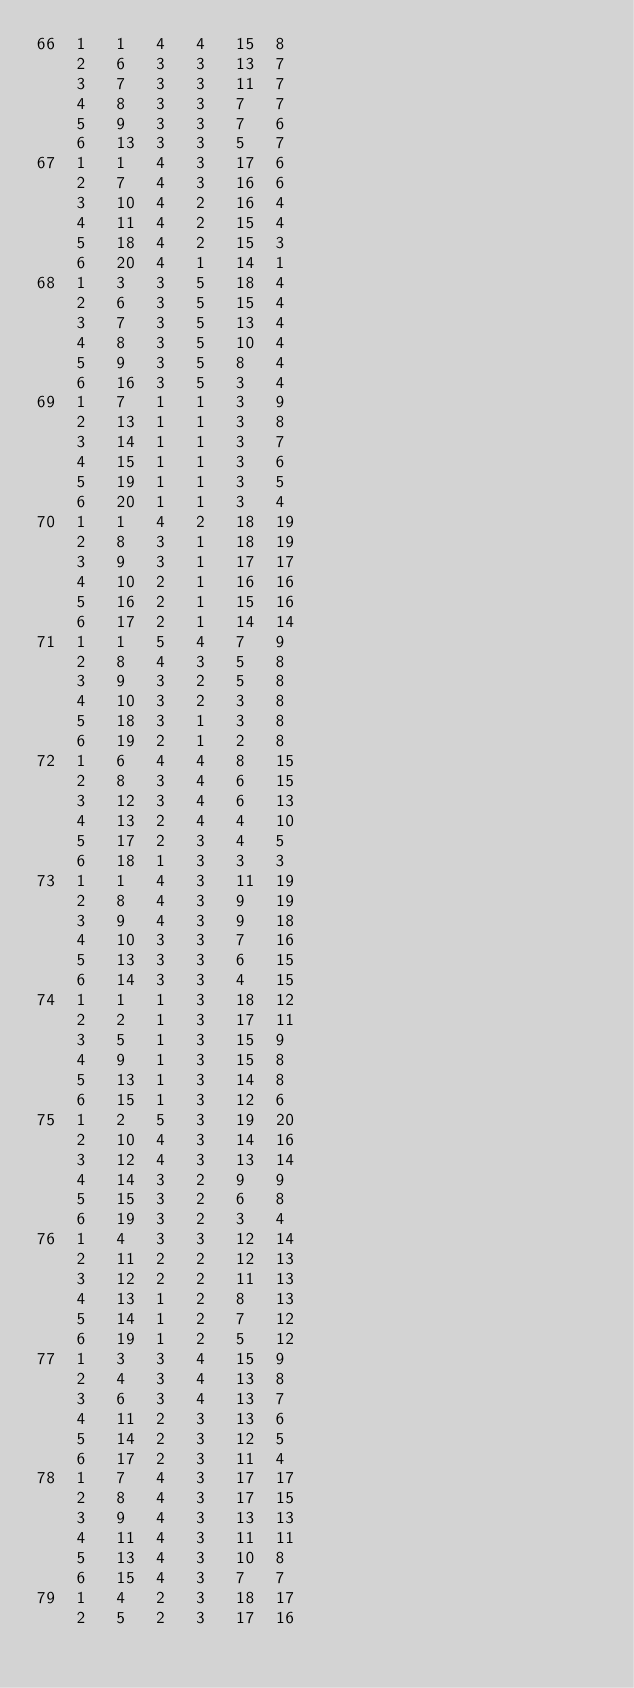<code> <loc_0><loc_0><loc_500><loc_500><_ObjectiveC_>66	1	1	4	4	15	8	
	2	6	3	3	13	7	
	3	7	3	3	11	7	
	4	8	3	3	7	7	
	5	9	3	3	7	6	
	6	13	3	3	5	7	
67	1	1	4	3	17	6	
	2	7	4	3	16	6	
	3	10	4	2	16	4	
	4	11	4	2	15	4	
	5	18	4	2	15	3	
	6	20	4	1	14	1	
68	1	3	3	5	18	4	
	2	6	3	5	15	4	
	3	7	3	5	13	4	
	4	8	3	5	10	4	
	5	9	3	5	8	4	
	6	16	3	5	3	4	
69	1	7	1	1	3	9	
	2	13	1	1	3	8	
	3	14	1	1	3	7	
	4	15	1	1	3	6	
	5	19	1	1	3	5	
	6	20	1	1	3	4	
70	1	1	4	2	18	19	
	2	8	3	1	18	19	
	3	9	3	1	17	17	
	4	10	2	1	16	16	
	5	16	2	1	15	16	
	6	17	2	1	14	14	
71	1	1	5	4	7	9	
	2	8	4	3	5	8	
	3	9	3	2	5	8	
	4	10	3	2	3	8	
	5	18	3	1	3	8	
	6	19	2	1	2	8	
72	1	6	4	4	8	15	
	2	8	3	4	6	15	
	3	12	3	4	6	13	
	4	13	2	4	4	10	
	5	17	2	3	4	5	
	6	18	1	3	3	3	
73	1	1	4	3	11	19	
	2	8	4	3	9	19	
	3	9	4	3	9	18	
	4	10	3	3	7	16	
	5	13	3	3	6	15	
	6	14	3	3	4	15	
74	1	1	1	3	18	12	
	2	2	1	3	17	11	
	3	5	1	3	15	9	
	4	9	1	3	15	8	
	5	13	1	3	14	8	
	6	15	1	3	12	6	
75	1	2	5	3	19	20	
	2	10	4	3	14	16	
	3	12	4	3	13	14	
	4	14	3	2	9	9	
	5	15	3	2	6	8	
	6	19	3	2	3	4	
76	1	4	3	3	12	14	
	2	11	2	2	12	13	
	3	12	2	2	11	13	
	4	13	1	2	8	13	
	5	14	1	2	7	12	
	6	19	1	2	5	12	
77	1	3	3	4	15	9	
	2	4	3	4	13	8	
	3	6	3	4	13	7	
	4	11	2	3	13	6	
	5	14	2	3	12	5	
	6	17	2	3	11	4	
78	1	7	4	3	17	17	
	2	8	4	3	17	15	
	3	9	4	3	13	13	
	4	11	4	3	11	11	
	5	13	4	3	10	8	
	6	15	4	3	7	7	
79	1	4	2	3	18	17	
	2	5	2	3	17	16	</code> 